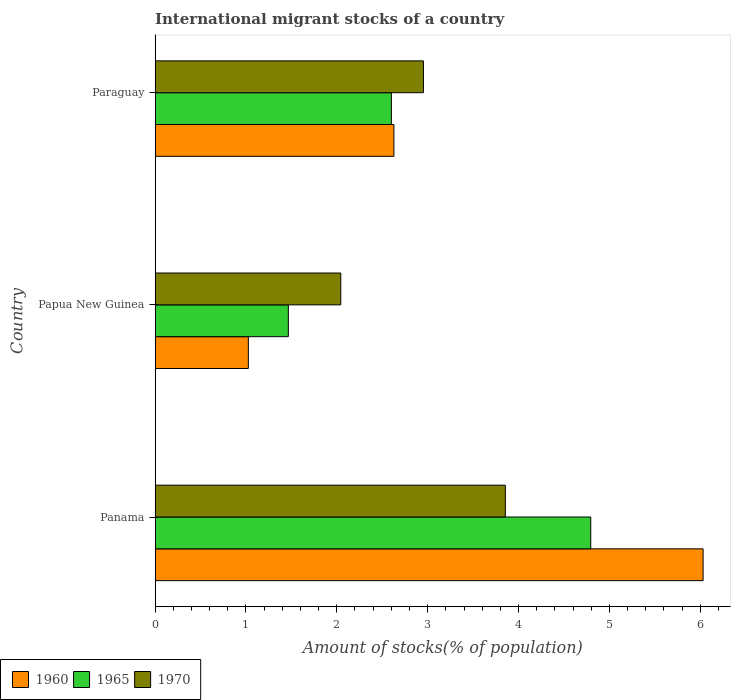How many different coloured bars are there?
Keep it short and to the point. 3. How many groups of bars are there?
Keep it short and to the point. 3. Are the number of bars on each tick of the Y-axis equal?
Offer a terse response. Yes. How many bars are there on the 1st tick from the bottom?
Provide a succinct answer. 3. What is the label of the 1st group of bars from the top?
Keep it short and to the point. Paraguay. What is the amount of stocks in in 1965 in Paraguay?
Your answer should be very brief. 2.6. Across all countries, what is the maximum amount of stocks in in 1965?
Provide a short and direct response. 4.79. Across all countries, what is the minimum amount of stocks in in 1965?
Make the answer very short. 1.47. In which country was the amount of stocks in in 1965 maximum?
Give a very brief answer. Panama. In which country was the amount of stocks in in 1965 minimum?
Your answer should be compact. Papua New Guinea. What is the total amount of stocks in in 1965 in the graph?
Your response must be concise. 8.86. What is the difference between the amount of stocks in in 1970 in Panama and that in Papua New Guinea?
Make the answer very short. 1.81. What is the difference between the amount of stocks in in 1960 in Panama and the amount of stocks in in 1970 in Paraguay?
Offer a terse response. 3.08. What is the average amount of stocks in in 1965 per country?
Give a very brief answer. 2.95. What is the difference between the amount of stocks in in 1970 and amount of stocks in in 1960 in Panama?
Your answer should be very brief. -2.18. What is the ratio of the amount of stocks in in 1960 in Panama to that in Paraguay?
Your answer should be compact. 2.29. Is the amount of stocks in in 1970 in Papua New Guinea less than that in Paraguay?
Offer a very short reply. Yes. What is the difference between the highest and the second highest amount of stocks in in 1970?
Make the answer very short. 0.9. What is the difference between the highest and the lowest amount of stocks in in 1970?
Keep it short and to the point. 1.81. Is the sum of the amount of stocks in in 1965 in Panama and Papua New Guinea greater than the maximum amount of stocks in in 1970 across all countries?
Your response must be concise. Yes. Is it the case that in every country, the sum of the amount of stocks in in 1960 and amount of stocks in in 1970 is greater than the amount of stocks in in 1965?
Offer a very short reply. Yes. How many bars are there?
Keep it short and to the point. 9. Are all the bars in the graph horizontal?
Ensure brevity in your answer.  Yes. Does the graph contain any zero values?
Keep it short and to the point. No. Where does the legend appear in the graph?
Keep it short and to the point. Bottom left. What is the title of the graph?
Offer a very short reply. International migrant stocks of a country. What is the label or title of the X-axis?
Make the answer very short. Amount of stocks(% of population). What is the Amount of stocks(% of population) in 1960 in Panama?
Provide a succinct answer. 6.03. What is the Amount of stocks(% of population) in 1965 in Panama?
Ensure brevity in your answer.  4.79. What is the Amount of stocks(% of population) in 1970 in Panama?
Your response must be concise. 3.85. What is the Amount of stocks(% of population) in 1960 in Papua New Guinea?
Offer a very short reply. 1.03. What is the Amount of stocks(% of population) in 1965 in Papua New Guinea?
Give a very brief answer. 1.47. What is the Amount of stocks(% of population) of 1970 in Papua New Guinea?
Give a very brief answer. 2.04. What is the Amount of stocks(% of population) of 1960 in Paraguay?
Provide a short and direct response. 2.63. What is the Amount of stocks(% of population) of 1965 in Paraguay?
Your answer should be compact. 2.6. What is the Amount of stocks(% of population) in 1970 in Paraguay?
Your answer should be very brief. 2.95. Across all countries, what is the maximum Amount of stocks(% of population) in 1960?
Offer a very short reply. 6.03. Across all countries, what is the maximum Amount of stocks(% of population) of 1965?
Offer a terse response. 4.79. Across all countries, what is the maximum Amount of stocks(% of population) of 1970?
Keep it short and to the point. 3.85. Across all countries, what is the minimum Amount of stocks(% of population) in 1960?
Keep it short and to the point. 1.03. Across all countries, what is the minimum Amount of stocks(% of population) of 1965?
Ensure brevity in your answer.  1.47. Across all countries, what is the minimum Amount of stocks(% of population) of 1970?
Give a very brief answer. 2.04. What is the total Amount of stocks(% of population) in 1960 in the graph?
Ensure brevity in your answer.  9.69. What is the total Amount of stocks(% of population) in 1965 in the graph?
Your answer should be very brief. 8.86. What is the total Amount of stocks(% of population) in 1970 in the graph?
Give a very brief answer. 8.85. What is the difference between the Amount of stocks(% of population) of 1960 in Panama and that in Papua New Guinea?
Your response must be concise. 5. What is the difference between the Amount of stocks(% of population) in 1965 in Panama and that in Papua New Guinea?
Keep it short and to the point. 3.33. What is the difference between the Amount of stocks(% of population) of 1970 in Panama and that in Papua New Guinea?
Provide a short and direct response. 1.81. What is the difference between the Amount of stocks(% of population) in 1960 in Panama and that in Paraguay?
Ensure brevity in your answer.  3.4. What is the difference between the Amount of stocks(% of population) of 1965 in Panama and that in Paraguay?
Your answer should be very brief. 2.19. What is the difference between the Amount of stocks(% of population) of 1970 in Panama and that in Paraguay?
Give a very brief answer. 0.9. What is the difference between the Amount of stocks(% of population) of 1960 in Papua New Guinea and that in Paraguay?
Provide a short and direct response. -1.6. What is the difference between the Amount of stocks(% of population) in 1965 in Papua New Guinea and that in Paraguay?
Provide a succinct answer. -1.13. What is the difference between the Amount of stocks(% of population) in 1970 in Papua New Guinea and that in Paraguay?
Keep it short and to the point. -0.91. What is the difference between the Amount of stocks(% of population) of 1960 in Panama and the Amount of stocks(% of population) of 1965 in Papua New Guinea?
Offer a very short reply. 4.56. What is the difference between the Amount of stocks(% of population) of 1960 in Panama and the Amount of stocks(% of population) of 1970 in Papua New Guinea?
Your response must be concise. 3.99. What is the difference between the Amount of stocks(% of population) in 1965 in Panama and the Amount of stocks(% of population) in 1970 in Papua New Guinea?
Offer a very short reply. 2.75. What is the difference between the Amount of stocks(% of population) in 1960 in Panama and the Amount of stocks(% of population) in 1965 in Paraguay?
Provide a succinct answer. 3.43. What is the difference between the Amount of stocks(% of population) of 1960 in Panama and the Amount of stocks(% of population) of 1970 in Paraguay?
Give a very brief answer. 3.08. What is the difference between the Amount of stocks(% of population) of 1965 in Panama and the Amount of stocks(% of population) of 1970 in Paraguay?
Your response must be concise. 1.84. What is the difference between the Amount of stocks(% of population) in 1960 in Papua New Guinea and the Amount of stocks(% of population) in 1965 in Paraguay?
Keep it short and to the point. -1.57. What is the difference between the Amount of stocks(% of population) of 1960 in Papua New Guinea and the Amount of stocks(% of population) of 1970 in Paraguay?
Keep it short and to the point. -1.93. What is the difference between the Amount of stocks(% of population) of 1965 in Papua New Guinea and the Amount of stocks(% of population) of 1970 in Paraguay?
Offer a very short reply. -1.49. What is the average Amount of stocks(% of population) in 1960 per country?
Provide a succinct answer. 3.23. What is the average Amount of stocks(% of population) in 1965 per country?
Keep it short and to the point. 2.95. What is the average Amount of stocks(% of population) of 1970 per country?
Provide a short and direct response. 2.95. What is the difference between the Amount of stocks(% of population) of 1960 and Amount of stocks(% of population) of 1965 in Panama?
Offer a terse response. 1.24. What is the difference between the Amount of stocks(% of population) in 1960 and Amount of stocks(% of population) in 1970 in Panama?
Offer a very short reply. 2.18. What is the difference between the Amount of stocks(% of population) of 1965 and Amount of stocks(% of population) of 1970 in Panama?
Your response must be concise. 0.94. What is the difference between the Amount of stocks(% of population) of 1960 and Amount of stocks(% of population) of 1965 in Papua New Guinea?
Your answer should be very brief. -0.44. What is the difference between the Amount of stocks(% of population) in 1960 and Amount of stocks(% of population) in 1970 in Papua New Guinea?
Your response must be concise. -1.02. What is the difference between the Amount of stocks(% of population) of 1965 and Amount of stocks(% of population) of 1970 in Papua New Guinea?
Your answer should be compact. -0.58. What is the difference between the Amount of stocks(% of population) in 1960 and Amount of stocks(% of population) in 1965 in Paraguay?
Keep it short and to the point. 0.03. What is the difference between the Amount of stocks(% of population) of 1960 and Amount of stocks(% of population) of 1970 in Paraguay?
Offer a terse response. -0.32. What is the difference between the Amount of stocks(% of population) in 1965 and Amount of stocks(% of population) in 1970 in Paraguay?
Provide a short and direct response. -0.35. What is the ratio of the Amount of stocks(% of population) of 1960 in Panama to that in Papua New Guinea?
Give a very brief answer. 5.88. What is the ratio of the Amount of stocks(% of population) of 1965 in Panama to that in Papua New Guinea?
Your answer should be compact. 3.27. What is the ratio of the Amount of stocks(% of population) in 1970 in Panama to that in Papua New Guinea?
Keep it short and to the point. 1.89. What is the ratio of the Amount of stocks(% of population) in 1960 in Panama to that in Paraguay?
Your answer should be very brief. 2.29. What is the ratio of the Amount of stocks(% of population) in 1965 in Panama to that in Paraguay?
Give a very brief answer. 1.84. What is the ratio of the Amount of stocks(% of population) of 1970 in Panama to that in Paraguay?
Make the answer very short. 1.31. What is the ratio of the Amount of stocks(% of population) in 1960 in Papua New Guinea to that in Paraguay?
Ensure brevity in your answer.  0.39. What is the ratio of the Amount of stocks(% of population) in 1965 in Papua New Guinea to that in Paraguay?
Provide a short and direct response. 0.56. What is the ratio of the Amount of stocks(% of population) in 1970 in Papua New Guinea to that in Paraguay?
Keep it short and to the point. 0.69. What is the difference between the highest and the second highest Amount of stocks(% of population) of 1960?
Your response must be concise. 3.4. What is the difference between the highest and the second highest Amount of stocks(% of population) in 1965?
Your answer should be compact. 2.19. What is the difference between the highest and the second highest Amount of stocks(% of population) of 1970?
Provide a succinct answer. 0.9. What is the difference between the highest and the lowest Amount of stocks(% of population) in 1960?
Provide a short and direct response. 5. What is the difference between the highest and the lowest Amount of stocks(% of population) of 1965?
Give a very brief answer. 3.33. What is the difference between the highest and the lowest Amount of stocks(% of population) in 1970?
Your answer should be very brief. 1.81. 